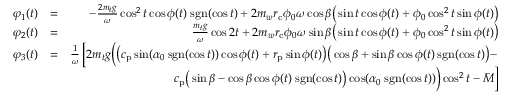<formula> <loc_0><loc_0><loc_500><loc_500>\begin{array} { r l r } { \varphi _ { 1 } ( t ) } & { = } & { - \frac { 2 m _ { t } g } { \omega } \cos ^ { 2 } t \cos \phi ( t ) \, s g n ( \cos t ) + 2 m _ { w } r _ { c } \phi _ { 0 } \omega \cos \beta \left ( \sin t \cos \phi ( t ) + \phi _ { 0 } \cos ^ { 2 } t \sin \phi ( t ) \right ) } \\ { \varphi _ { 2 } ( t ) } & { = } & { \frac { m _ { t } g } { \omega } \cos 2 t + 2 m _ { w } r _ { c } \phi _ { 0 } \omega \sin \beta \left ( \sin t \cos \phi ( t ) + \phi _ { 0 } \cos ^ { 2 } t \sin \phi ( t ) \right ) } \\ { \varphi _ { 3 } ( t ) } & { = } & { \frac { 1 } { \omega } \left [ 2 m _ { t } g \left ( \left ( c _ { p } \sin ( \alpha _ { 0 } \, s g n ( \cos t ) ) \cos \phi ( t ) + r _ { p } \sin \phi ( t ) \right ) \left ( \cos \beta + \sin \beta \cos \phi ( t ) \, s g n ( \cos t ) \right ) - } \\ & { c _ { p } \left ( \sin \beta - \cos \beta \cos \phi ( t ) \, s g n ( \cos t ) \right ) \cos ( \alpha _ { 0 } \, s g n ( \cos t ) ) \right ) \cos ^ { 2 } t - \bar { M } \right ] } \end{array}</formula> 